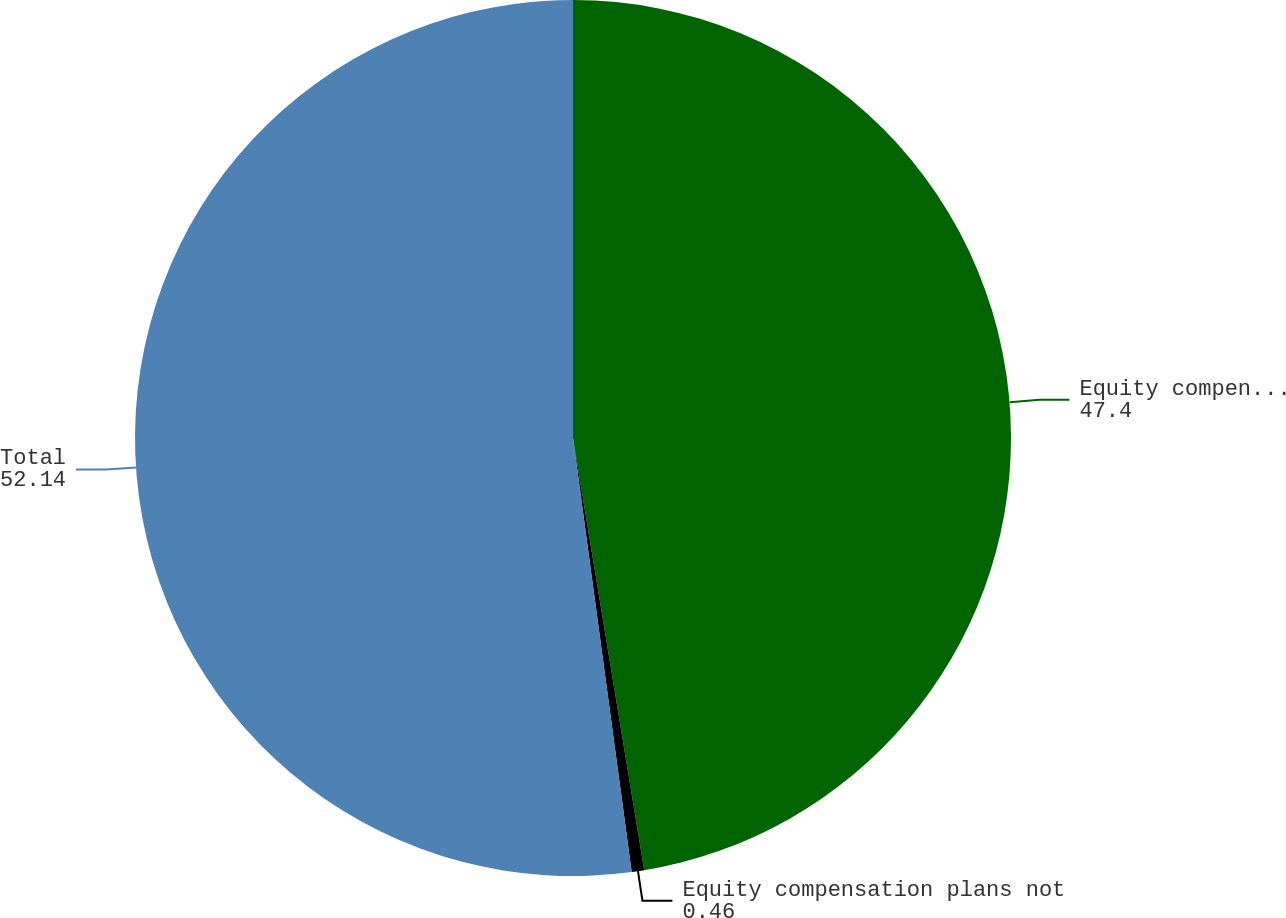<chart> <loc_0><loc_0><loc_500><loc_500><pie_chart><fcel>Equity compensation plans<fcel>Equity compensation plans not<fcel>Total<nl><fcel>47.4%<fcel>0.46%<fcel>52.14%<nl></chart> 